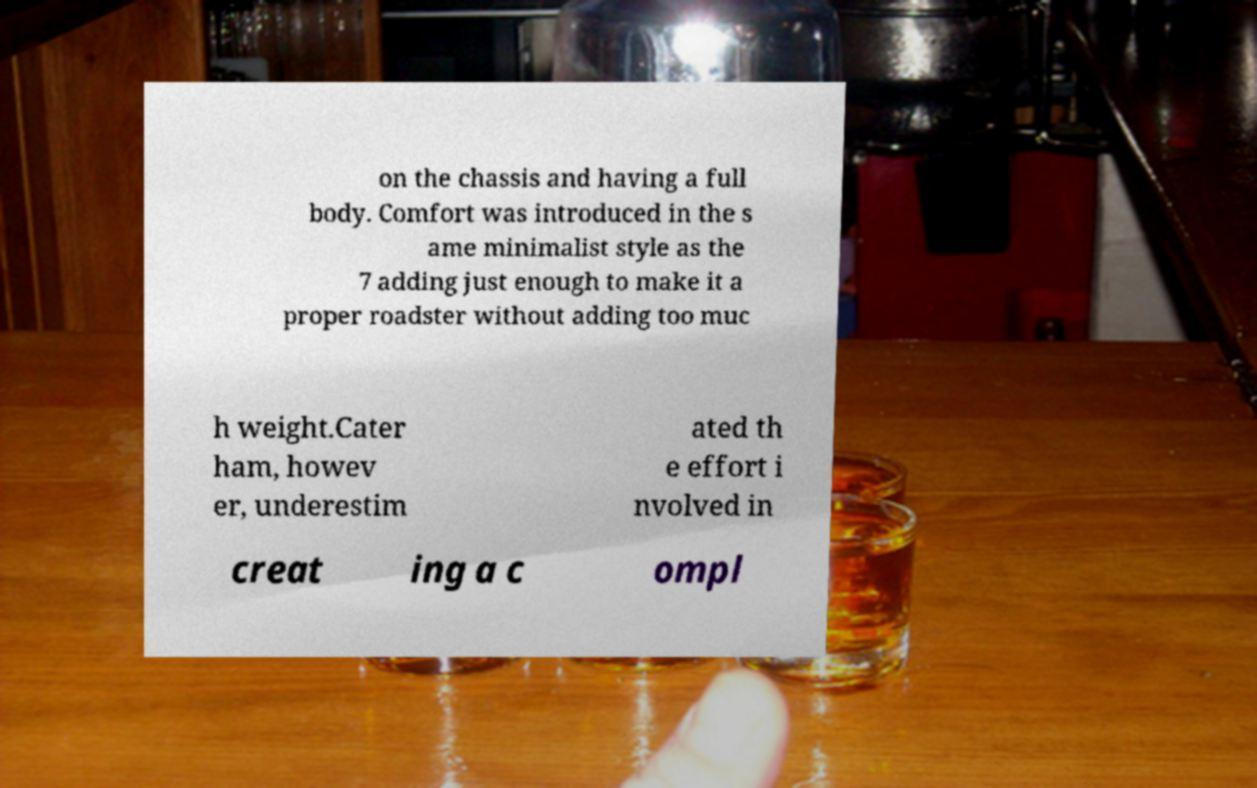For documentation purposes, I need the text within this image transcribed. Could you provide that? on the chassis and having a full body. Comfort was introduced in the s ame minimalist style as the 7 adding just enough to make it a proper roadster without adding too muc h weight.Cater ham, howev er, underestim ated th e effort i nvolved in creat ing a c ompl 